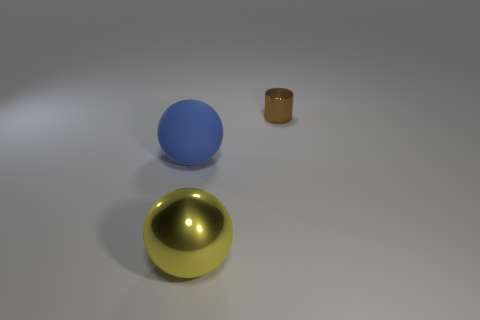There is a blue matte object; does it have the same shape as the thing that is in front of the big blue matte object?
Provide a succinct answer. Yes. Are there more brown shiny cylinders behind the blue object than yellow metal cubes?
Make the answer very short. Yes. Is the number of small shiny things to the right of the small brown thing less than the number of large purple things?
Keep it short and to the point. No. How many large metallic objects have the same color as the tiny thing?
Make the answer very short. 0. What material is the thing that is both on the left side of the small metal cylinder and behind the big metal thing?
Offer a very short reply. Rubber. What number of yellow things are either metal cylinders or big spheres?
Provide a succinct answer. 1. Are there fewer tiny brown metal objects that are in front of the blue rubber object than small metal cylinders right of the yellow shiny sphere?
Your answer should be very brief. Yes. Are there any rubber balls of the same size as the shiny sphere?
Make the answer very short. Yes. There is a ball on the right side of the blue sphere; is its size the same as the large blue matte sphere?
Your answer should be very brief. Yes. Is the number of large yellow metal balls greater than the number of tiny rubber blocks?
Your response must be concise. Yes. 